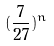Convert formula to latex. <formula><loc_0><loc_0><loc_500><loc_500>( \frac { 7 } { 2 7 } ) ^ { n }</formula> 